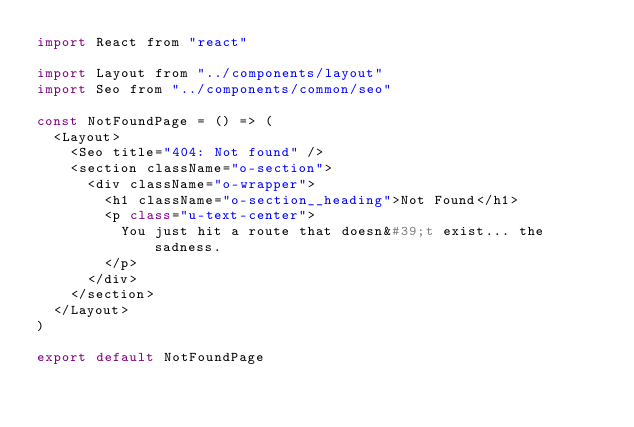<code> <loc_0><loc_0><loc_500><loc_500><_JavaScript_>import React from "react"

import Layout from "../components/layout"
import Seo from "../components/common/seo"

const NotFoundPage = () => (
  <Layout>
    <Seo title="404: Not found" />
    <section className="o-section">
      <div className="o-wrapper">
        <h1 className="o-section__heading">Not Found</h1>
        <p class="u-text-center">
          You just hit a route that doesn&#39;t exist... the sadness.
        </p>
      </div>
    </section>
  </Layout>
)

export default NotFoundPage
</code> 